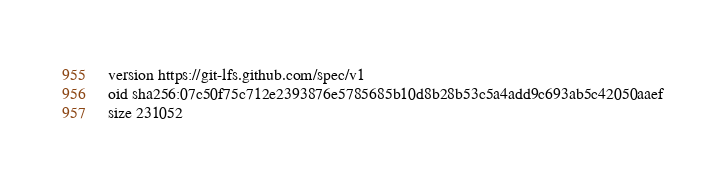<code> <loc_0><loc_0><loc_500><loc_500><_TypeScript_>version https://git-lfs.github.com/spec/v1
oid sha256:07c50f75c712e2393876e5785685b10d8b28b53c5a4add9c693ab5c42050aaef
size 231052
</code> 